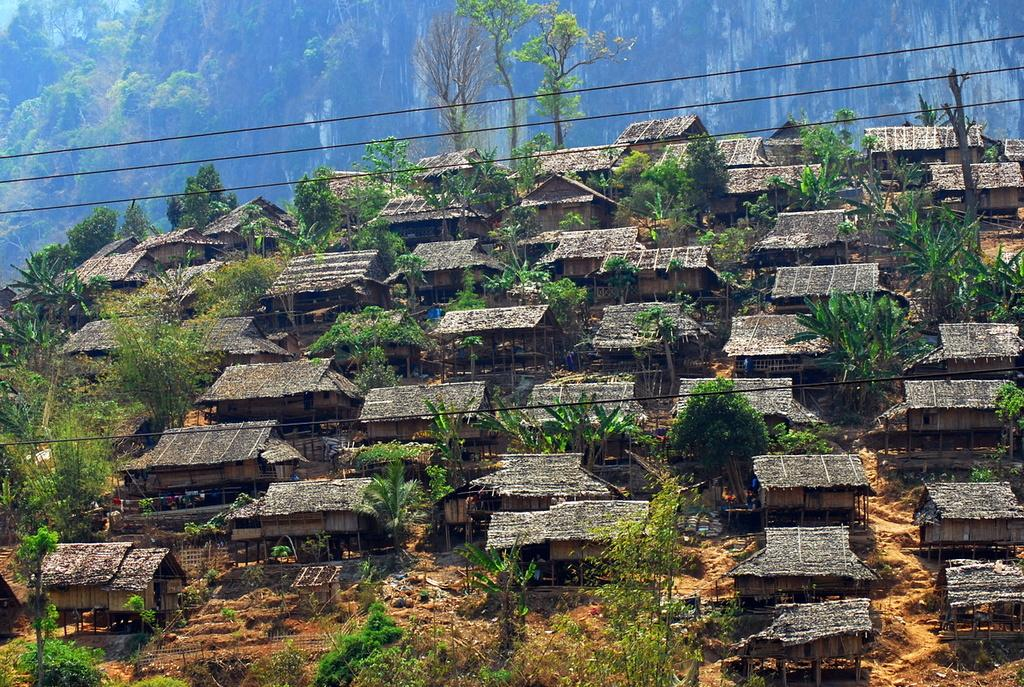What type of structures are present in the image? There are houses in the image. What other natural elements can be seen in the image? There are trees and fences visible in the image. What is located in the background of the image? In the background of the image, there is a hill. Are there any additional trees visible in the image? Yes, trees are visible in the background of the image. What type of skin condition can be seen on the houses in the image? There is no mention of any skin condition in the image, as the houses are structures and not living organisms. 